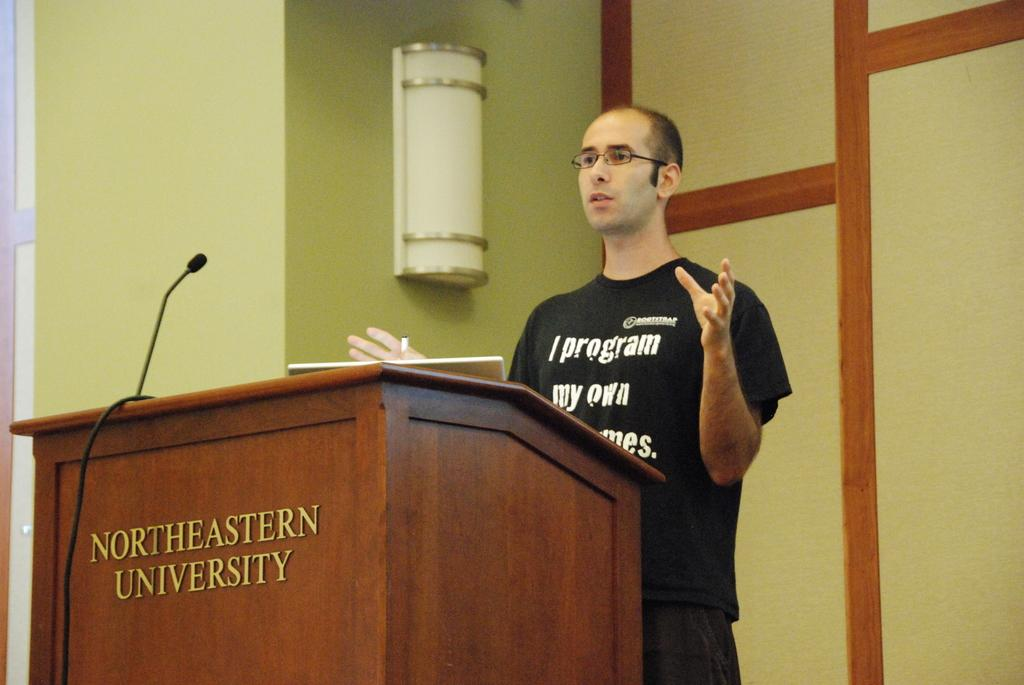What can be seen in the left corner of the image? There is a wall in the left corner of the image. What is located on the wall in the background of the image? There is a wall with an object on it in the background of the image. What is the person in the foreground of the image doing? The facts do not specify what the person is doing, so we cannot answer this question definitively. What is on the podium in the image? There is a microphone on the podium in the image. What type of rule is being enforced by the person in the image? There is no indication of any rule or enforcement in the image, so we cannot answer this question definitively. What is the root of the tree in the image? There is no tree present in the image, so we cannot answer this question definitively. 